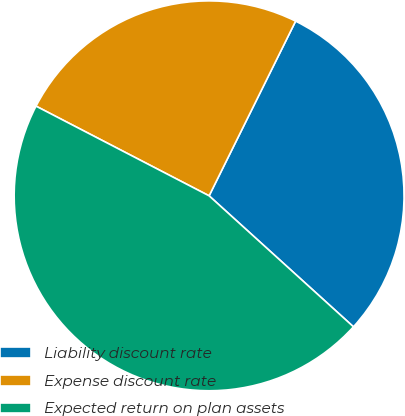Convert chart. <chart><loc_0><loc_0><loc_500><loc_500><pie_chart><fcel>Liability discount rate<fcel>Expense discount rate<fcel>Expected return on plan assets<nl><fcel>29.41%<fcel>24.71%<fcel>45.88%<nl></chart> 